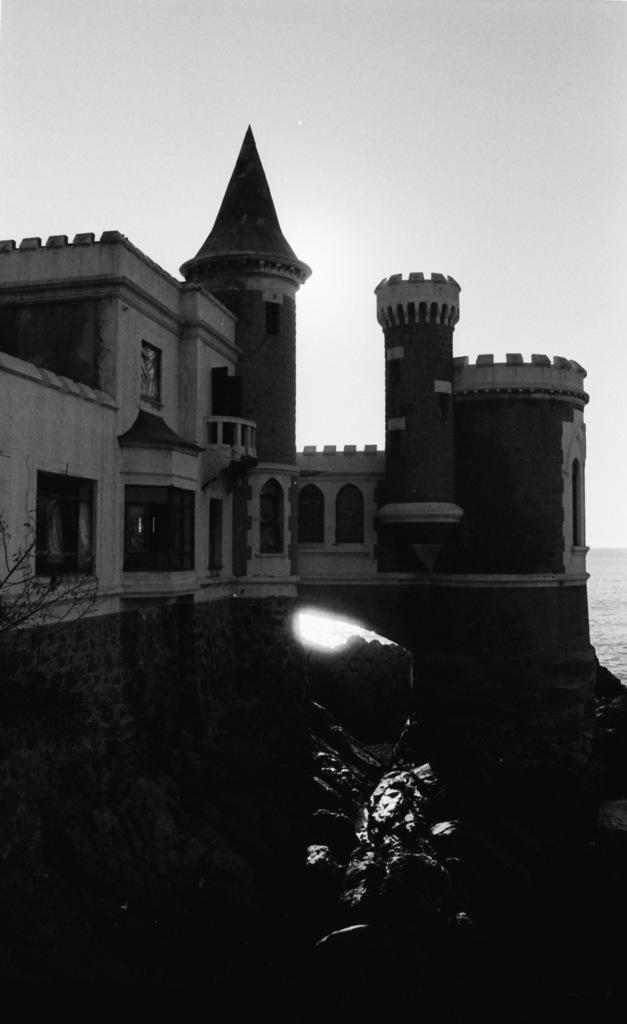What is the color scheme of the image? The image is black and white. What can be seen on the right side of the image? There is water on the right side of the image. What structure is located in the middle of the image? There is a building in the middle of the image. What is visible at the top of the image? The sky is visible at the top of the image. What type of vegetation is on the left side of the image? There is a tree on the left side of the image. Can you see a hand holding the tree in the image? There is no hand visible in the image, and the tree is not being held by any object or person. Is there an owl perched on the building in the image? There is no owl present in the image; only the building, water, sky, and tree are visible. 